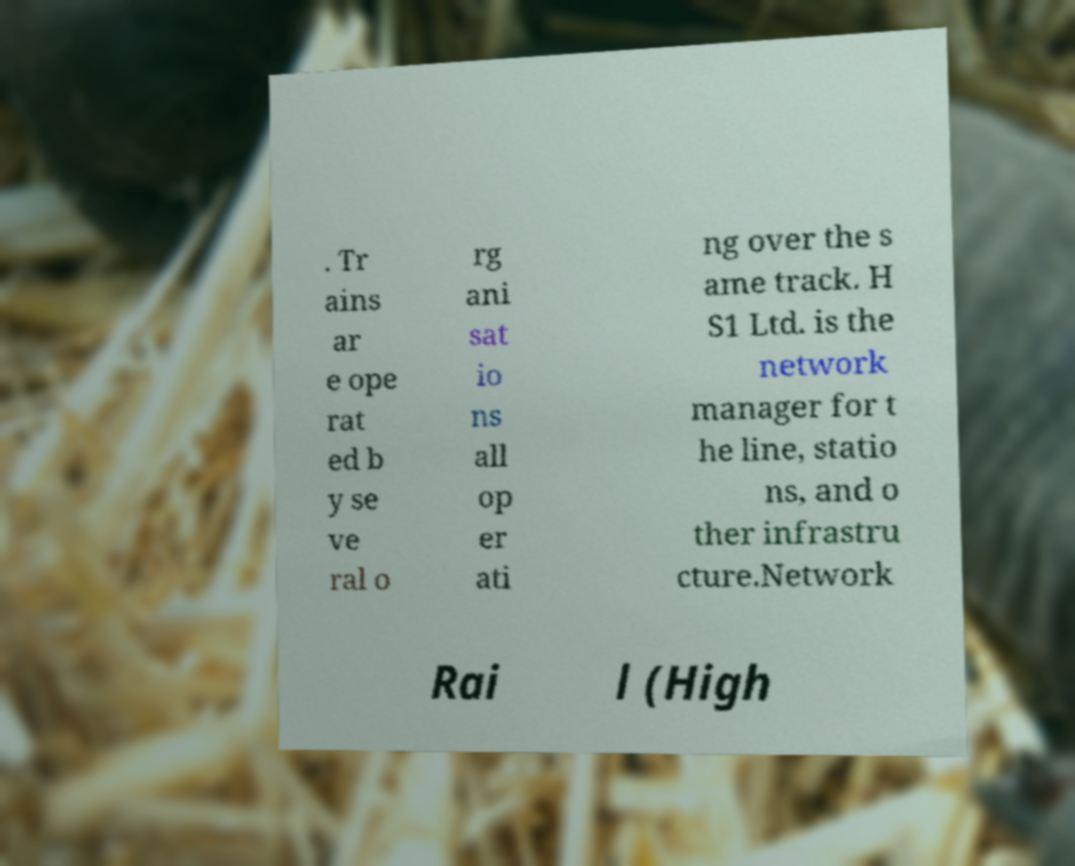Please read and relay the text visible in this image. What does it say? . Tr ains ar e ope rat ed b y se ve ral o rg ani sat io ns all op er ati ng over the s ame track. H S1 Ltd. is the network manager for t he line, statio ns, and o ther infrastru cture.Network Rai l (High 